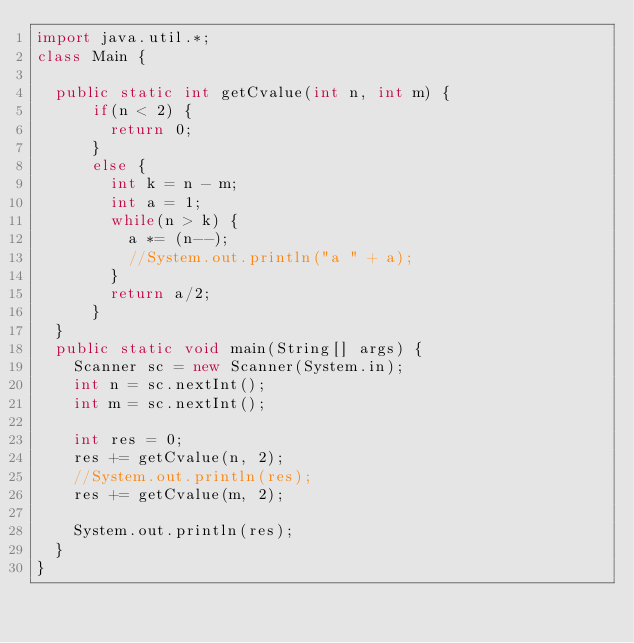<code> <loc_0><loc_0><loc_500><loc_500><_Java_>import java.util.*;
class Main {

	public static int getCvalue(int n, int m) {
			if(n < 2) {
				return 0;
			}
			else {
				int k = n - m;
				int a = 1;
				while(n > k) {
					a *= (n--);
					//System.out.println("a " + a);
				}
				return a/2;
			}
	}
	public static void main(String[] args) {
		Scanner sc = new Scanner(System.in);
		int n = sc.nextInt();
		int m = sc.nextInt();

		int res = 0;
		res += getCvalue(n, 2);
		//System.out.println(res);
		res += getCvalue(m, 2);

		System.out.println(res);
	}
}</code> 